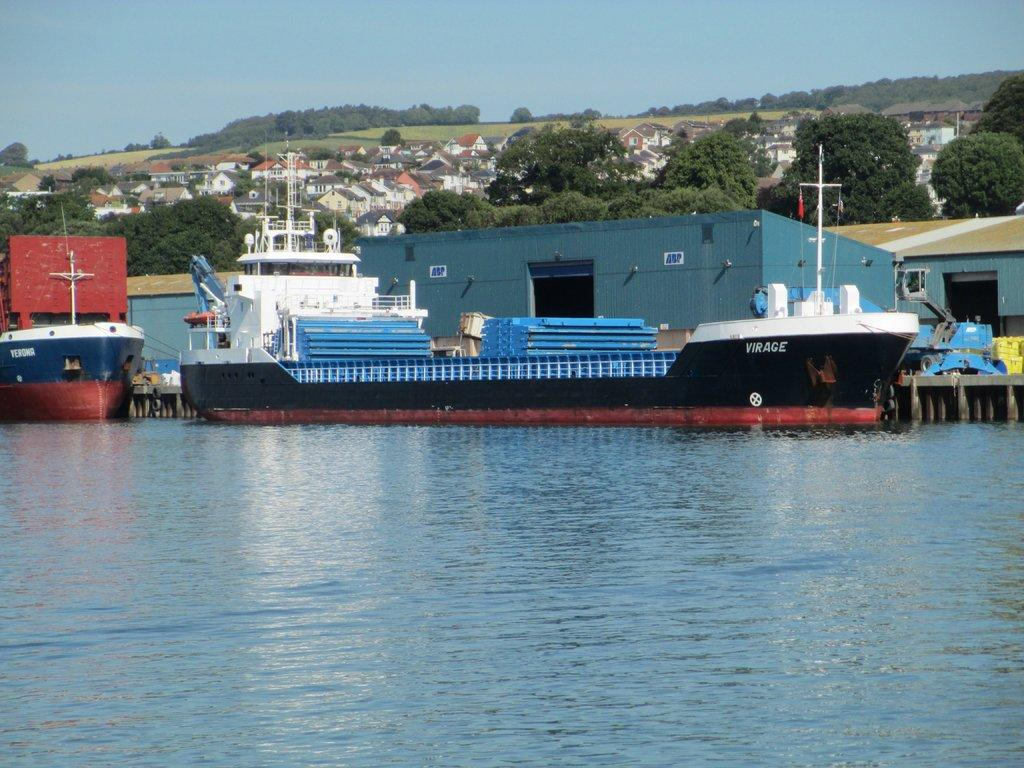What is in the foreground of the image? There is water in the foreground of the image. What can be seen in the middle of the image? There are ships in the middle of the image. What is visible in the background of the image? Shelters, trees, buildings, and grassland are visible in the background of the image. What is visible at the top of the image? The sky is visible at the top of the image. Can you tell me how many animals are depicted in the image? There are no animals present in the image. What level of expertise is required to begin using the shelters in the image? The image does not provide information about the level of expertise required to use the shelters. 